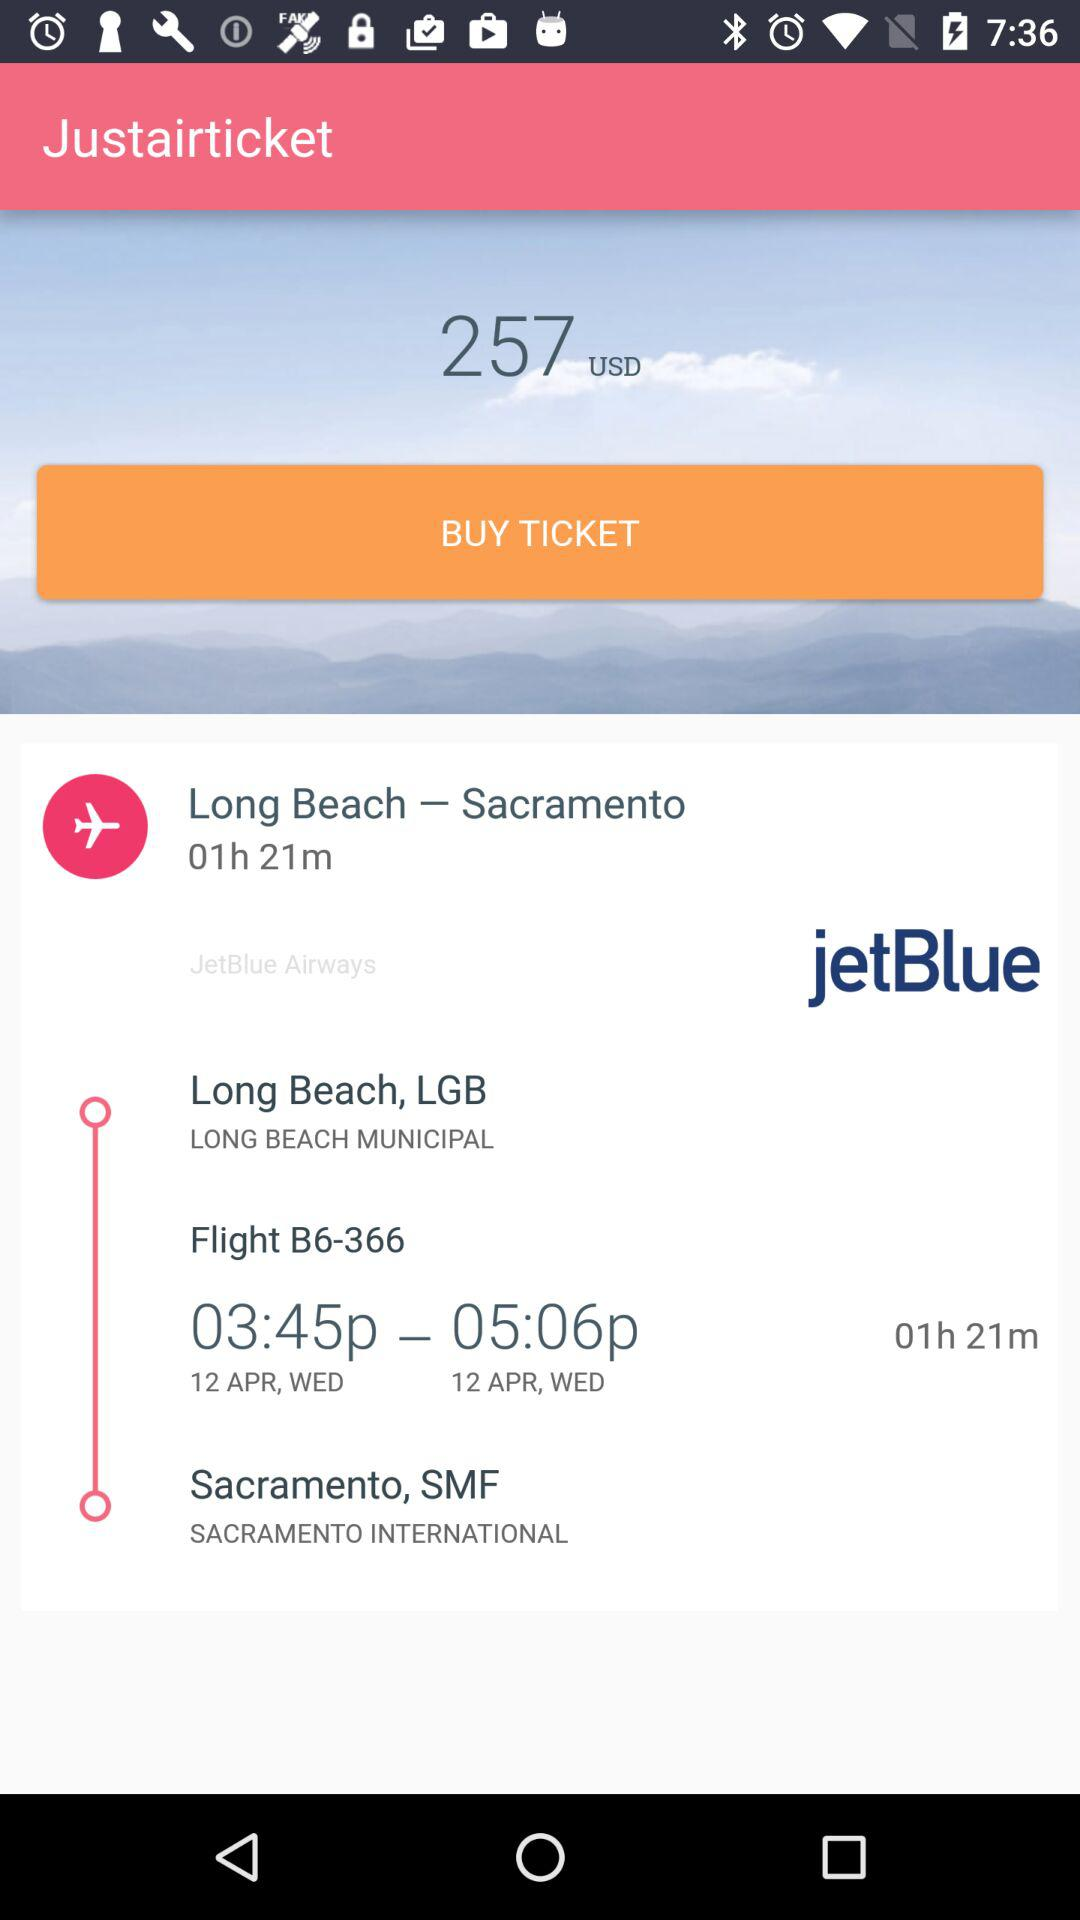How many hours is the flight?
Answer the question using a single word or phrase. 1 hour 21 minutes 